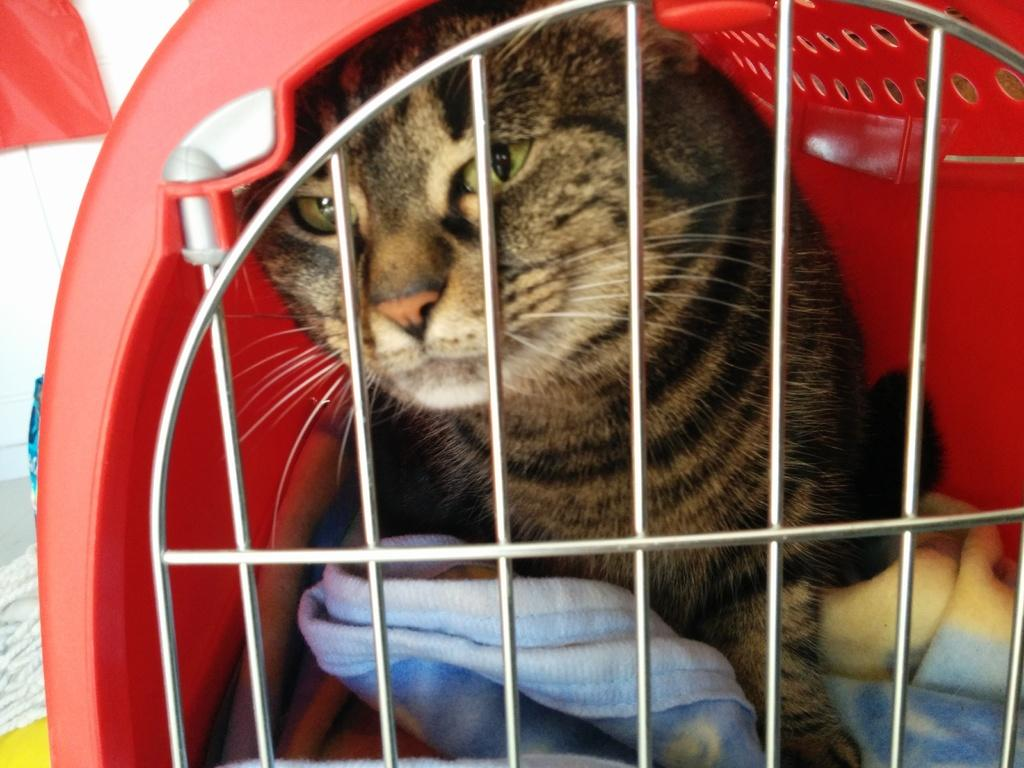What type of animal is present in the image? There is a cat in the image. Where is the cat located in the image? The cat is in a pet carrier. What color crayon can be seen in the image? There are no crayons present in the image. Is the cat going on vacation in the image? There is no indication of a vacation in the image; it simply shows a cat in a pet carrier. 